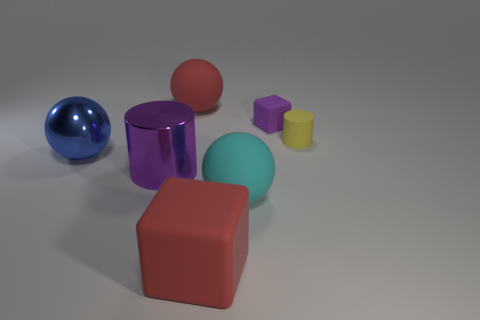Add 2 yellow rubber things. How many objects exist? 9 Subtract all cylinders. How many objects are left? 5 Subtract 0 cyan blocks. How many objects are left? 7 Subtract all tiny green rubber cubes. Subtract all red matte spheres. How many objects are left? 6 Add 3 cubes. How many cubes are left? 5 Add 1 blue shiny objects. How many blue shiny objects exist? 2 